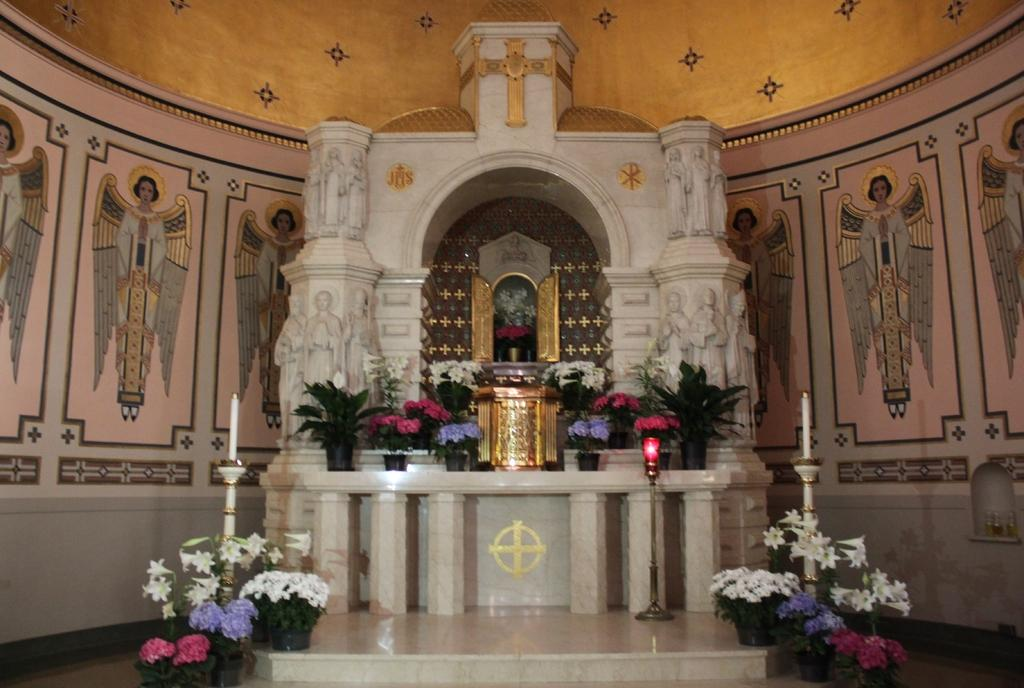What type of building is shown in the image? The image depicts the inside of a church. What decorative elements can be seen in the image? There are flowers and plants in the image. What objects are present that might be used for religious purposes? There are candles in the image. How many boys are participating in the action shown in the image? There are no boys or actions present in the image; it depicts the inside of a church with flowers, plants, and candles. 